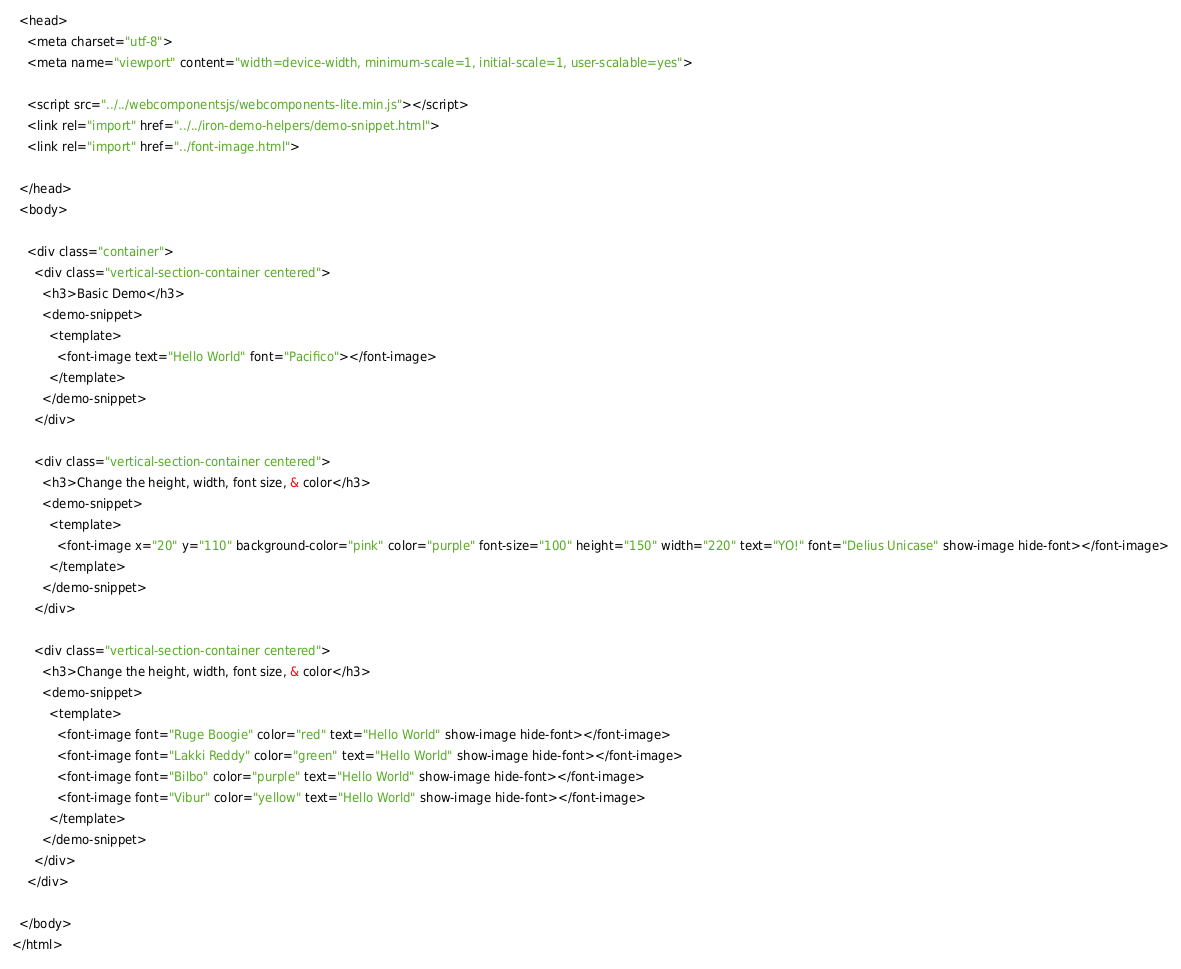Convert code to text. <code><loc_0><loc_0><loc_500><loc_500><_HTML_>  <head>
    <meta charset="utf-8">
    <meta name="viewport" content="width=device-width, minimum-scale=1, initial-scale=1, user-scalable=yes">

    <script src="../../webcomponentsjs/webcomponents-lite.min.js"></script>
    <link rel="import" href="../../iron-demo-helpers/demo-snippet.html">
    <link rel="import" href="../font-image.html">

  </head>
  <body>

    <div class="container">
      <div class="vertical-section-container centered">
        <h3>Basic Demo</h3>
        <demo-snippet>
          <template>
            <font-image text="Hello World" font="Pacifico"></font-image>
          </template>
        </demo-snippet>
      </div>

      <div class="vertical-section-container centered">
        <h3>Change the height, width, font size, & color</h3>
        <demo-snippet>
          <template>
            <font-image x="20" y="110" background-color="pink" color="purple" font-size="100" height="150" width="220" text="YO!" font="Delius Unicase" show-image hide-font></font-image>
          </template>
        </demo-snippet>
      </div>

      <div class="vertical-section-container centered">
        <h3>Change the height, width, font size, & color</h3>
        <demo-snippet>
          <template>
            <font-image font="Ruge Boogie" color="red" text="Hello World" show-image hide-font></font-image>
            <font-image font="Lakki Reddy" color="green" text="Hello World" show-image hide-font></font-image>
            <font-image font="Bilbo" color="purple" text="Hello World" show-image hide-font></font-image>
            <font-image font="Vibur" color="yellow" text="Hello World" show-image hide-font></font-image>
          </template>
        </demo-snippet>
      </div>
    </div>

  </body>
</html>
</code> 